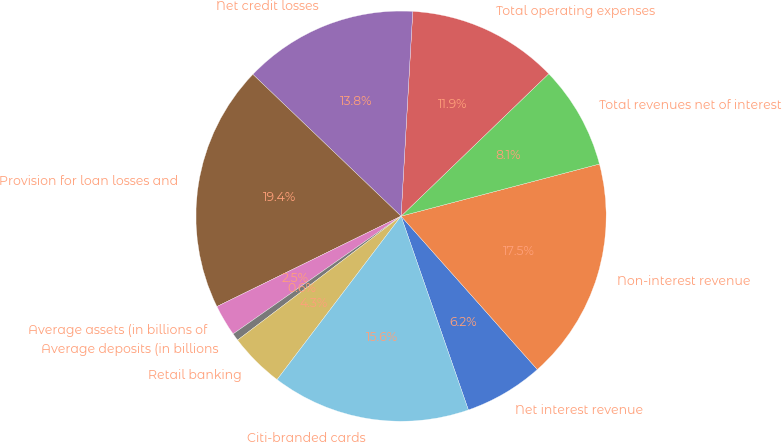Convert chart to OTSL. <chart><loc_0><loc_0><loc_500><loc_500><pie_chart><fcel>Net interest revenue<fcel>Non-interest revenue<fcel>Total revenues net of interest<fcel>Total operating expenses<fcel>Net credit losses<fcel>Provision for loan losses and<fcel>Average assets (in billions of<fcel>Average deposits (in billions<fcel>Retail banking<fcel>Citi-branded cards<nl><fcel>6.24%<fcel>17.53%<fcel>8.12%<fcel>11.88%<fcel>13.76%<fcel>19.41%<fcel>2.47%<fcel>0.59%<fcel>4.35%<fcel>15.65%<nl></chart> 